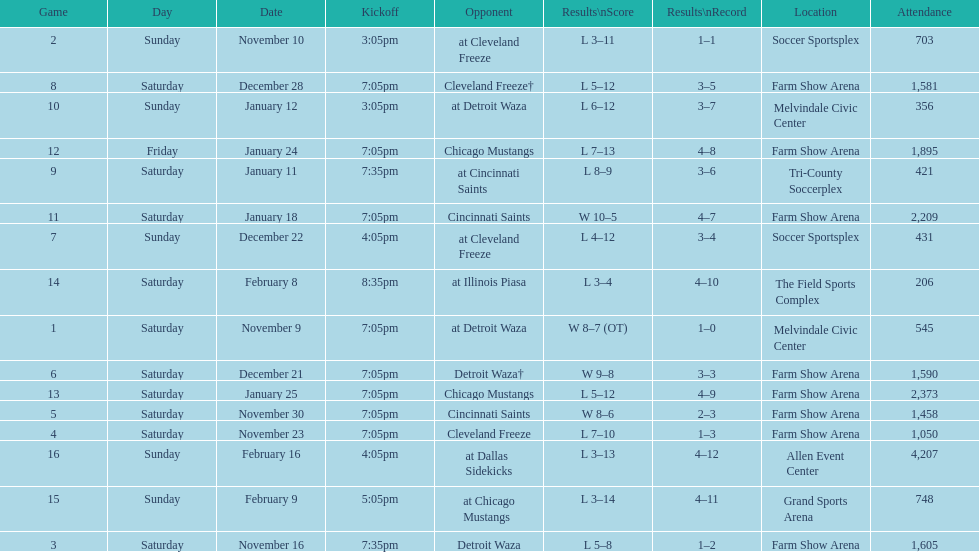How many times did the team play at home but did not win? 5. Help me parse the entirety of this table. {'header': ['Game', 'Day', 'Date', 'Kickoff', 'Opponent', 'Results\\nScore', 'Results\\nRecord', 'Location', 'Attendance'], 'rows': [['2', 'Sunday', 'November 10', '3:05pm', 'at Cleveland Freeze', 'L 3–11', '1–1', 'Soccer Sportsplex', '703'], ['8', 'Saturday', 'December 28', '7:05pm', 'Cleveland Freeze†', 'L 5–12', '3–5', 'Farm Show Arena', '1,581'], ['10', 'Sunday', 'January 12', '3:05pm', 'at Detroit Waza', 'L 6–12', '3–7', 'Melvindale Civic Center', '356'], ['12', 'Friday', 'January 24', '7:05pm', 'Chicago Mustangs', 'L 7–13', '4–8', 'Farm Show Arena', '1,895'], ['9', 'Saturday', 'January 11', '7:35pm', 'at Cincinnati Saints', 'L 8–9', '3–6', 'Tri-County Soccerplex', '421'], ['11', 'Saturday', 'January 18', '7:05pm', 'Cincinnati Saints', 'W 10–5', '4–7', 'Farm Show Arena', '2,209'], ['7', 'Sunday', 'December 22', '4:05pm', 'at Cleveland Freeze', 'L 4–12', '3–4', 'Soccer Sportsplex', '431'], ['14', 'Saturday', 'February 8', '8:35pm', 'at Illinois Piasa', 'L 3–4', '4–10', 'The Field Sports Complex', '206'], ['1', 'Saturday', 'November 9', '7:05pm', 'at Detroit Waza', 'W 8–7 (OT)', '1–0', 'Melvindale Civic Center', '545'], ['6', 'Saturday', 'December 21', '7:05pm', 'Detroit Waza†', 'W 9–8', '3–3', 'Farm Show Arena', '1,590'], ['13', 'Saturday', 'January 25', '7:05pm', 'Chicago Mustangs', 'L 5–12', '4–9', 'Farm Show Arena', '2,373'], ['5', 'Saturday', 'November 30', '7:05pm', 'Cincinnati Saints', 'W 8–6', '2–3', 'Farm Show Arena', '1,458'], ['4', 'Saturday', 'November 23', '7:05pm', 'Cleveland Freeze', 'L 7–10', '1–3', 'Farm Show Arena', '1,050'], ['16', 'Sunday', 'February 16', '4:05pm', 'at Dallas Sidekicks', 'L 3–13', '4–12', 'Allen Event Center', '4,207'], ['15', 'Sunday', 'February 9', '5:05pm', 'at Chicago Mustangs', 'L 3–14', '4–11', 'Grand Sports Arena', '748'], ['3', 'Saturday', 'November 16', '7:35pm', 'Detroit Waza', 'L 5–8', '1–2', 'Farm Show Arena', '1,605']]} 